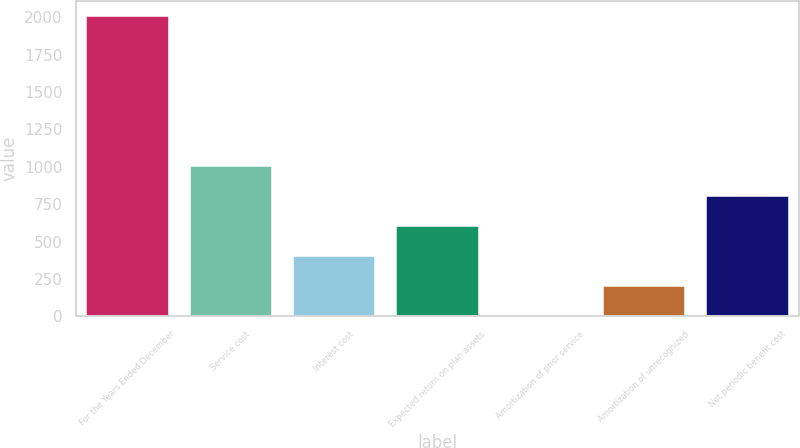<chart> <loc_0><loc_0><loc_500><loc_500><bar_chart><fcel>For the Years Ended December<fcel>Service cost<fcel>Interest cost<fcel>Expected return on plan assets<fcel>Amortization of prior service<fcel>Amortization of unrecognized<fcel>Net periodic benefit cost<nl><fcel>2012<fcel>1006.45<fcel>403.12<fcel>604.23<fcel>0.9<fcel>202.01<fcel>805.34<nl></chart> 